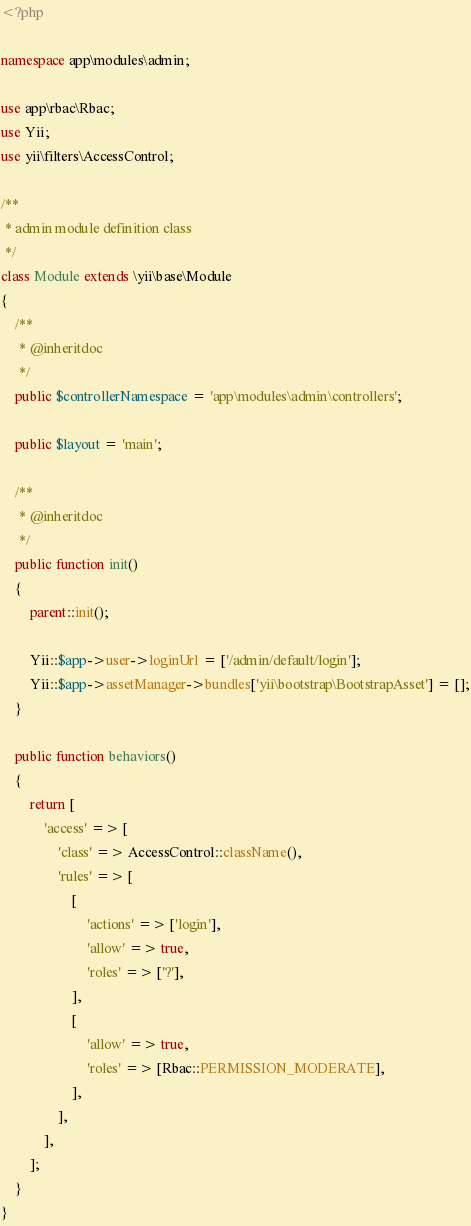Convert code to text. <code><loc_0><loc_0><loc_500><loc_500><_PHP_><?php

namespace app\modules\admin;

use app\rbac\Rbac;
use Yii;
use yii\filters\AccessControl;

/**
 * admin module definition class
 */
class Module extends \yii\base\Module
{
    /**
     * @inheritdoc
     */
    public $controllerNamespace = 'app\modules\admin\controllers';

    public $layout = 'main';

    /**
     * @inheritdoc
     */
    public function init()
    {
        parent::init();

        Yii::$app->user->loginUrl = ['/admin/default/login'];
        Yii::$app->assetManager->bundles['yii\bootstrap\BootstrapAsset'] = [];
    }

    public function behaviors()
    {
        return [
            'access' => [
                'class' => AccessControl::className(),
                'rules' => [
                    [
                        'actions' => ['login'],
                        'allow' => true,
                        'roles' => ['?'],
                    ],
                    [
                        'allow' => true,
                        'roles' => [Rbac::PERMISSION_MODERATE],
                    ],
                ],
            ],
        ];
    }
}
</code> 